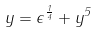Convert formula to latex. <formula><loc_0><loc_0><loc_500><loc_500>y = \epsilon ^ { \frac { 1 } { 4 } } + y ^ { 5 }</formula> 